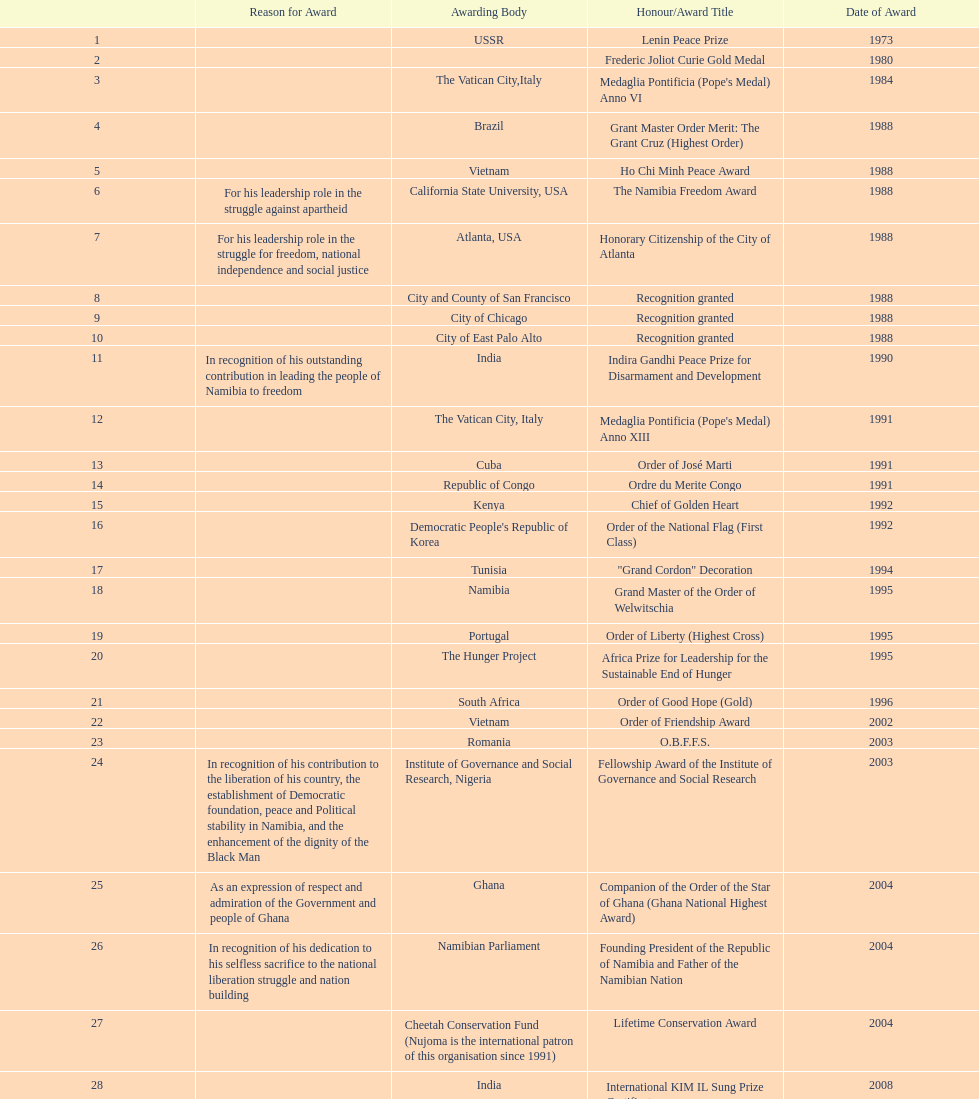What is the difference between the number of awards won in 1988 and the number of awards won in 1995? 4. 